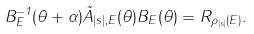<formula> <loc_0><loc_0><loc_500><loc_500>B _ { E } ^ { - 1 } ( \theta + \alpha ) \tilde { A } _ { | s | , E } ( \theta ) B _ { E } ( \theta ) = R _ { \rho _ { | s | } ( E ) } .</formula> 